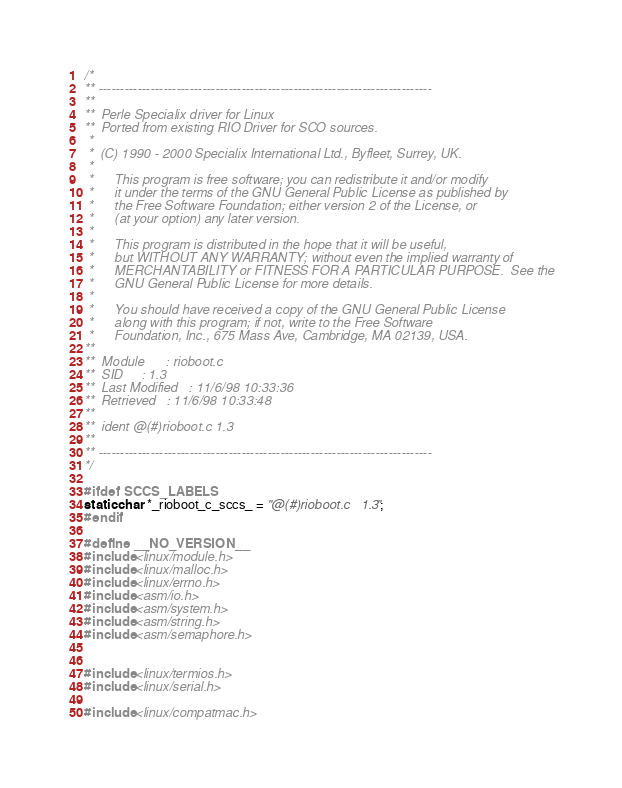Convert code to text. <code><loc_0><loc_0><loc_500><loc_500><_C_>/*
** -----------------------------------------------------------------------------
**
**  Perle Specialix driver for Linux
**  Ported from existing RIO Driver for SCO sources.
 *
 *  (C) 1990 - 2000 Specialix International Ltd., Byfleet, Surrey, UK.
 *
 *      This program is free software; you can redistribute it and/or modify
 *      it under the terms of the GNU General Public License as published by
 *      the Free Software Foundation; either version 2 of the License, or
 *      (at your option) any later version.
 *
 *      This program is distributed in the hope that it will be useful,
 *      but WITHOUT ANY WARRANTY; without even the implied warranty of
 *      MERCHANTABILITY or FITNESS FOR A PARTICULAR PURPOSE.  See the
 *      GNU General Public License for more details.
 *
 *      You should have received a copy of the GNU General Public License
 *      along with this program; if not, write to the Free Software
 *      Foundation, Inc., 675 Mass Ave, Cambridge, MA 02139, USA.
**
**	Module		: rioboot.c
**	SID		: 1.3
**	Last Modified	: 11/6/98 10:33:36
**	Retrieved	: 11/6/98 10:33:48
**
**  ident @(#)rioboot.c	1.3
**
** -----------------------------------------------------------------------------
*/

#ifdef SCCS_LABELS
static char *_rioboot_c_sccs_ = "@(#)rioboot.c	1.3";
#endif

#define __NO_VERSION__
#include <linux/module.h>
#include <linux/malloc.h>
#include <linux/errno.h>
#include <asm/io.h>
#include <asm/system.h>
#include <asm/string.h>
#include <asm/semaphore.h>


#include <linux/termios.h>
#include <linux/serial.h>

#include <linux/compatmac.h></code> 